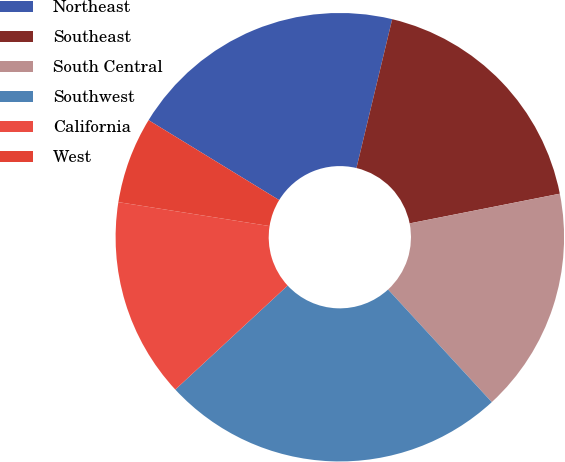<chart> <loc_0><loc_0><loc_500><loc_500><pie_chart><fcel>Northeast<fcel>Southeast<fcel>South Central<fcel>Southwest<fcel>California<fcel>West<nl><fcel>20.01%<fcel>18.14%<fcel>16.26%<fcel>24.96%<fcel>14.39%<fcel>6.24%<nl></chart> 